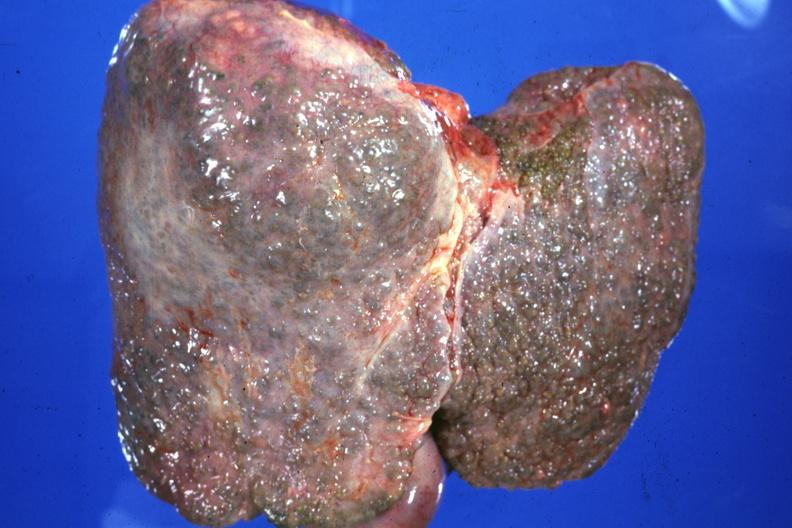s metastatic carcinoma breast present?
Answer the question using a single word or phrase. No 